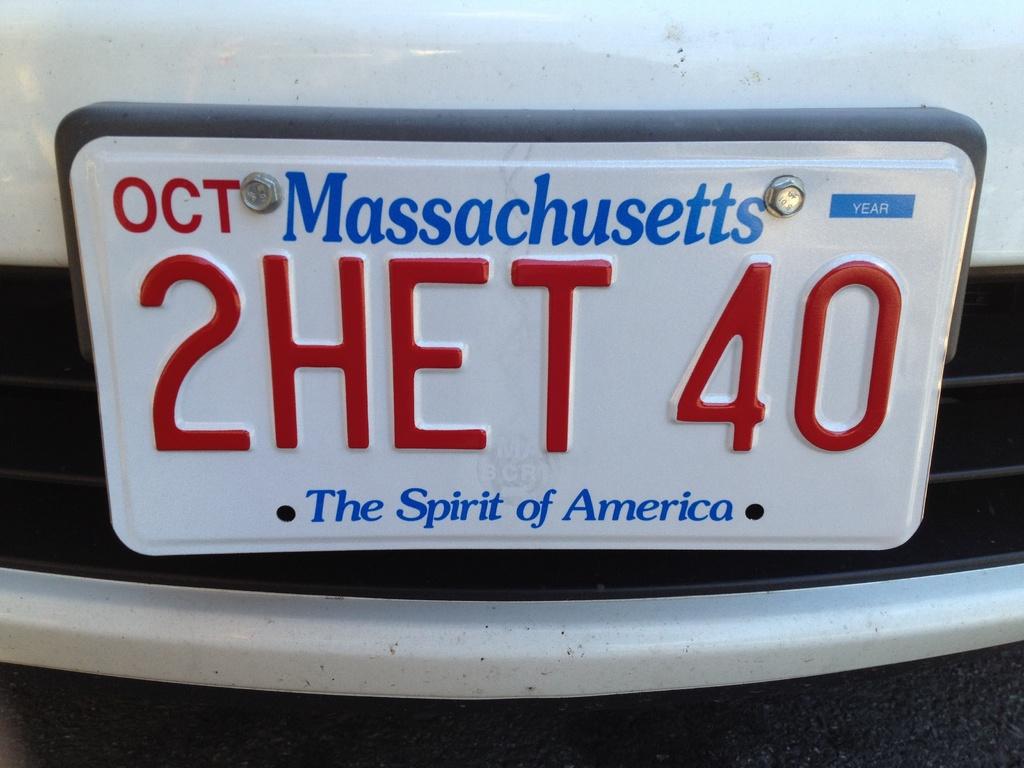What is the plate registration id?
Your answer should be very brief. 2het 40. What is the slogan of the state of massachusetts?
Keep it short and to the point. The spirit of america. 